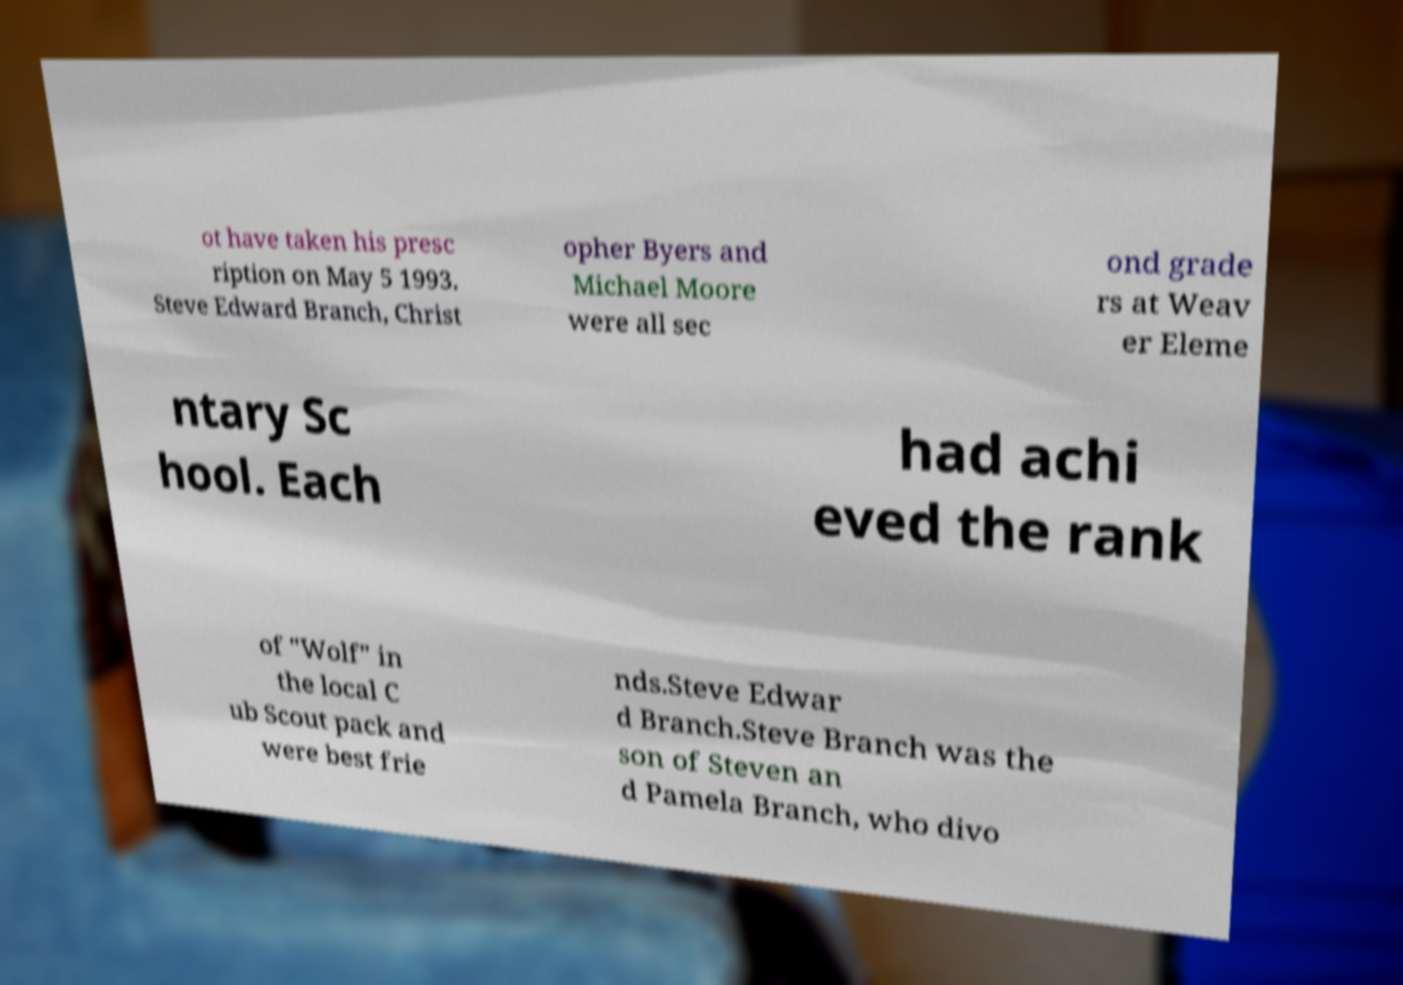Please identify and transcribe the text found in this image. ot have taken his presc ription on May 5 1993. Steve Edward Branch, Christ opher Byers and Michael Moore were all sec ond grade rs at Weav er Eleme ntary Sc hool. Each had achi eved the rank of "Wolf" in the local C ub Scout pack and were best frie nds.Steve Edwar d Branch.Steve Branch was the son of Steven an d Pamela Branch, who divo 